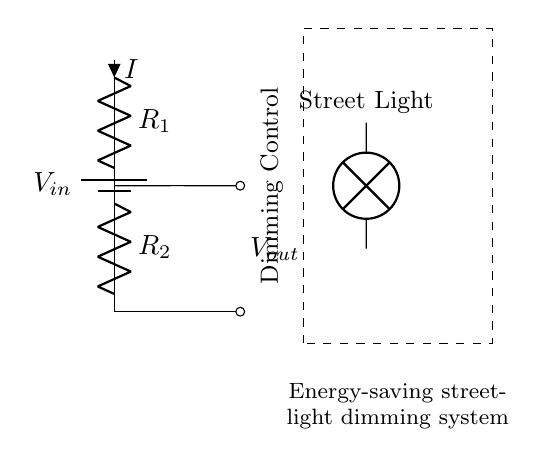What is the input voltage of this circuit? The input voltage is represented by the label V-in in the circuit diagram, indicating the voltage supplied to the circuit before it is divided.
Answer: V-in What does R-1 represent in the circuit? R-1 is a resistor in the circuit, specifically part of the voltage divider configuration, and it is labeled as such in the diagram.
Answer: Resistor What is the purpose of the dimming control? The dimming control, indicated by the dashed rectangle, adjusts the voltage output to the streetlight, ultimately controlling its brightness and energy consumption.
Answer: Adjusts voltage How does the voltage across R-2 compare to that across R-1? The voltage across R-2 can be less than or equal to the voltage across R-1 depending on their resistance values, following the voltage divider rule V-out = (R-2/(R-1 + R-2)) * V-in.
Answer: Depends on resistances What is V-out representing in this circuit? V-out represents the output voltage that will power the streetlight, showing how much voltage is available for use after the voltage division has occurred.
Answer: Output voltage If R-1 is double the resistance of R-2, how does that affect the brightness of the streetlight? If R-1 is double R-2, the output voltage V-out will be lower since it divides the input voltage in proportion to the resistor values, resulting in a dimmer streetlight.
Answer: Dims the light What type of circuit is this? This is a voltage divider circuit specifically designed to reduce voltage for applications such as dimming lights, which helps in controlling energy costs.
Answer: Voltage divider 